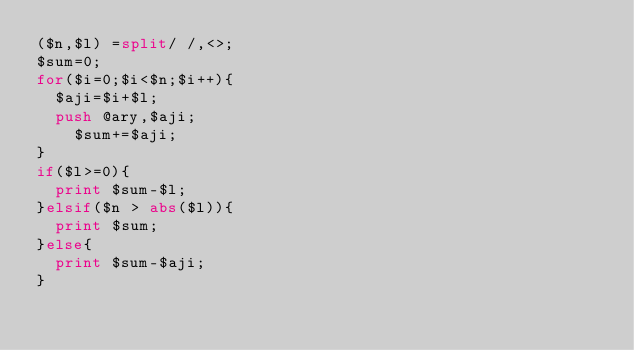Convert code to text. <code><loc_0><loc_0><loc_500><loc_500><_Perl_>($n,$l) =split/ /,<>;
$sum=0;
for($i=0;$i<$n;$i++){
	$aji=$i+$l;
	push @ary,$aji;
    $sum+=$aji;
}
if($l>=0){
	print $sum-$l;
}elsif($n > abs($l)){
	print $sum;
}else{
	print $sum-$aji;
}</code> 